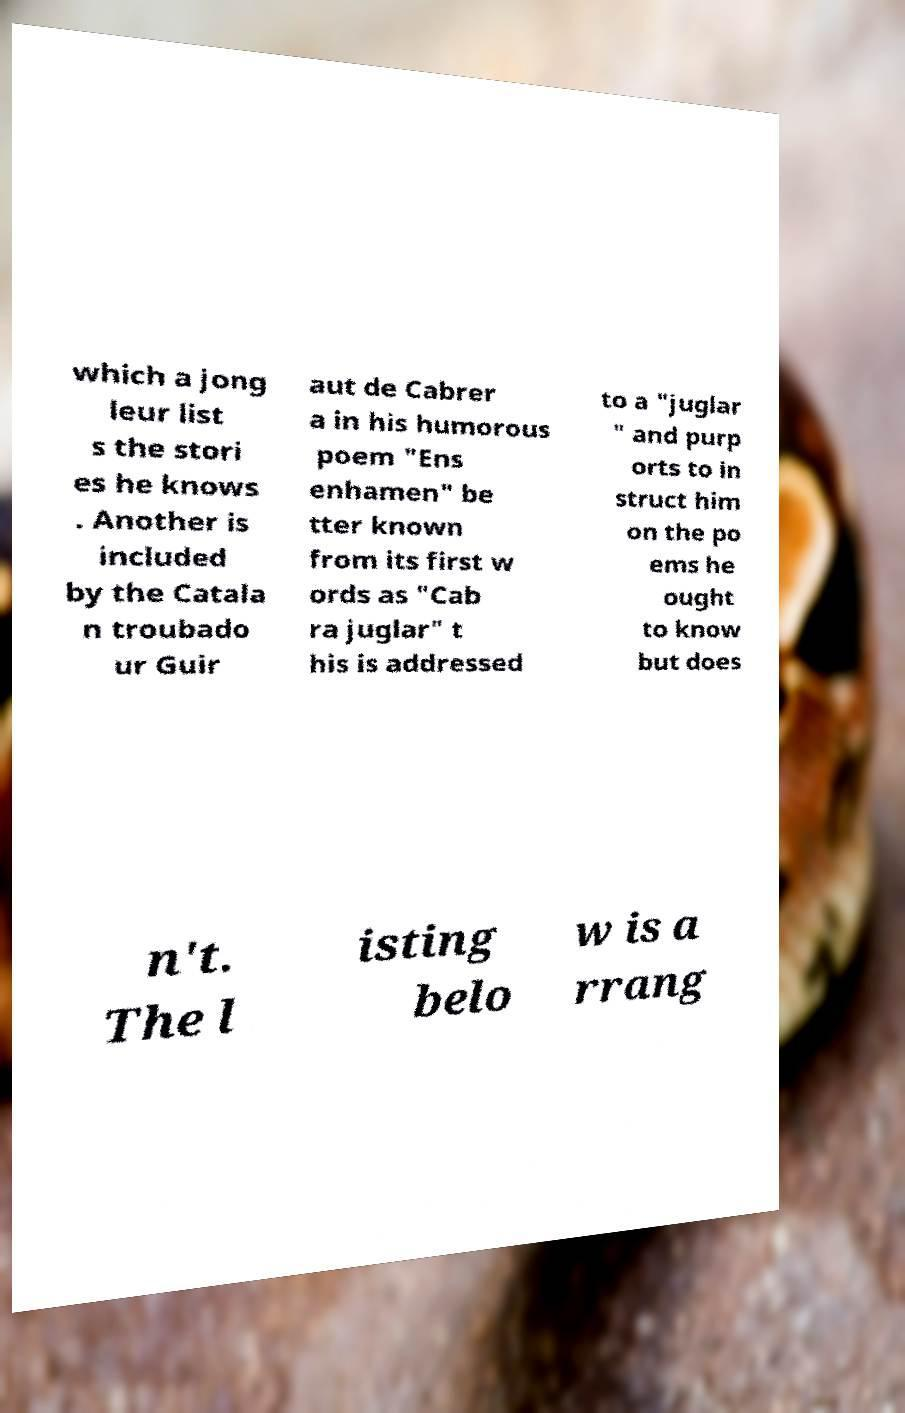For documentation purposes, I need the text within this image transcribed. Could you provide that? which a jong leur list s the stori es he knows . Another is included by the Catala n troubado ur Guir aut de Cabrer a in his humorous poem "Ens enhamen" be tter known from its first w ords as "Cab ra juglar" t his is addressed to a "juglar " and purp orts to in struct him on the po ems he ought to know but does n't. The l isting belo w is a rrang 